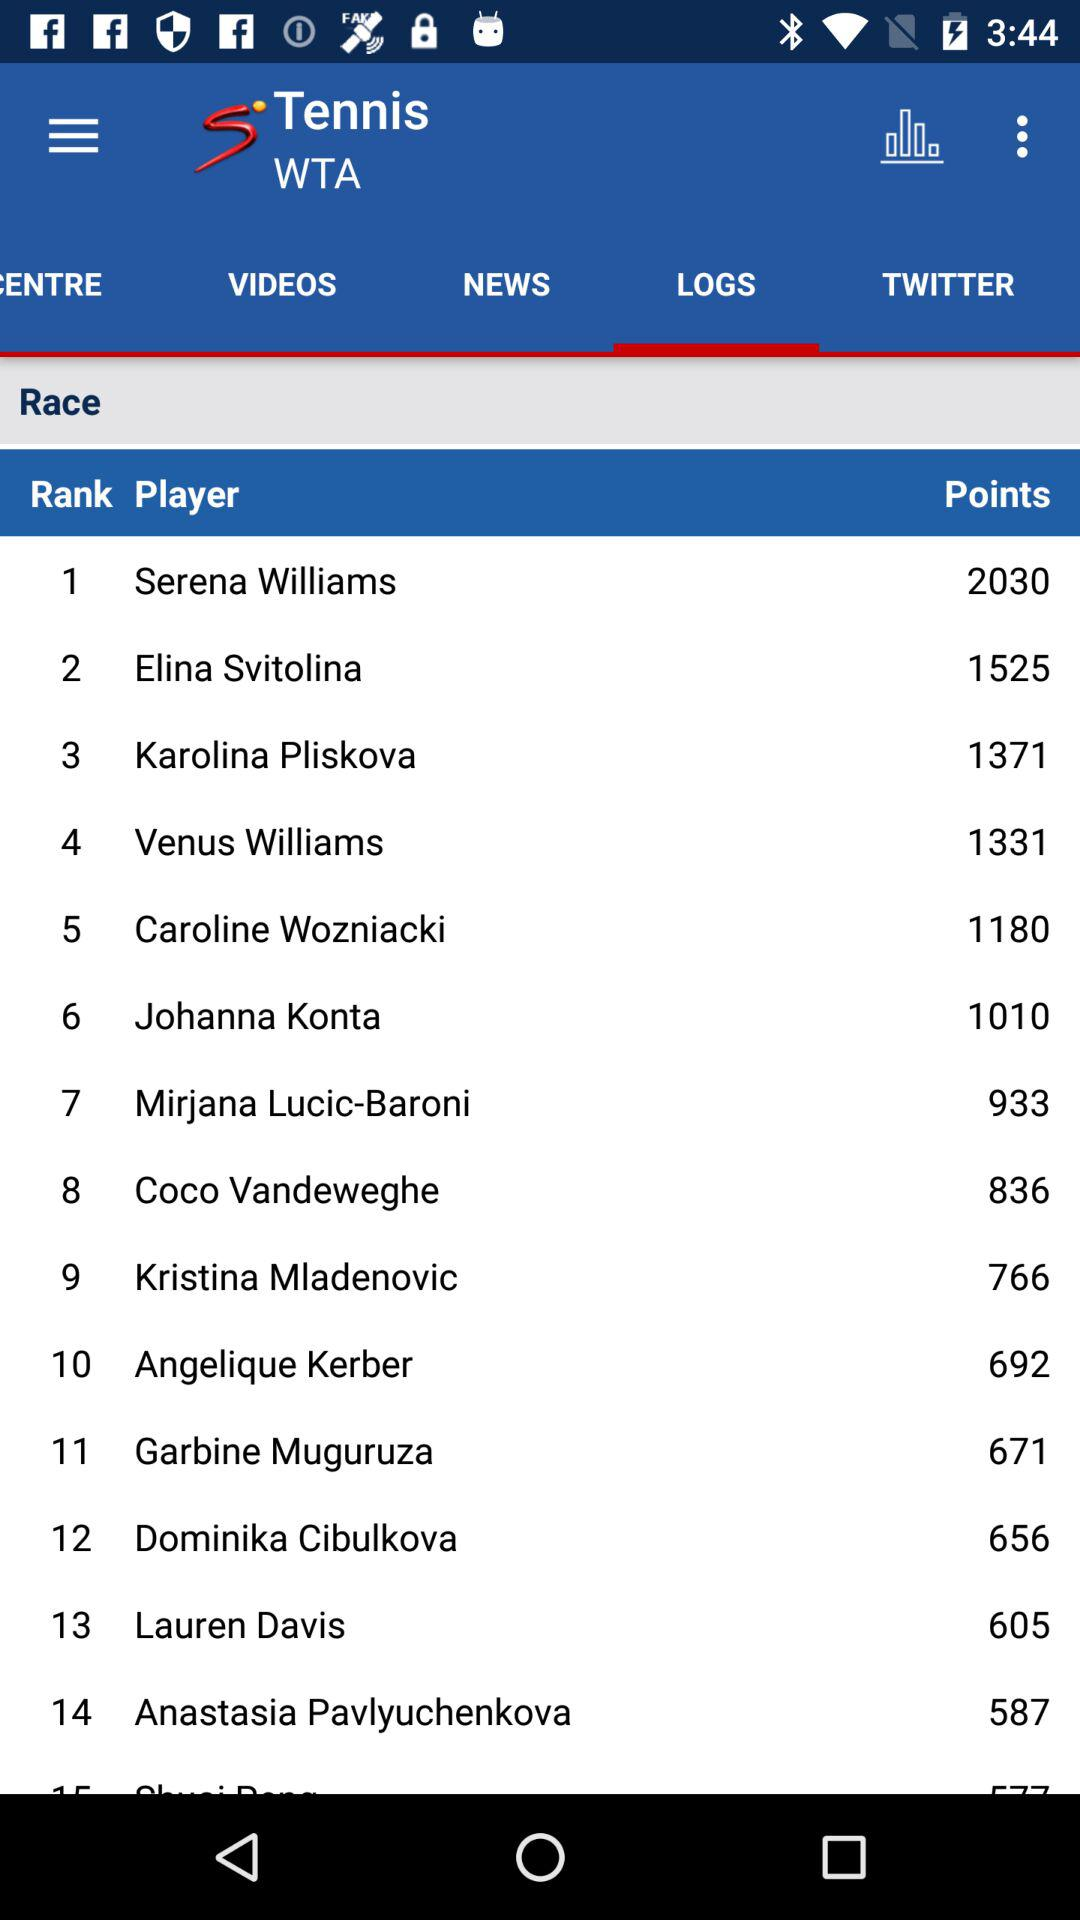How many points does Elina Svitolina have? Elina Svitolina has 1525 points. 